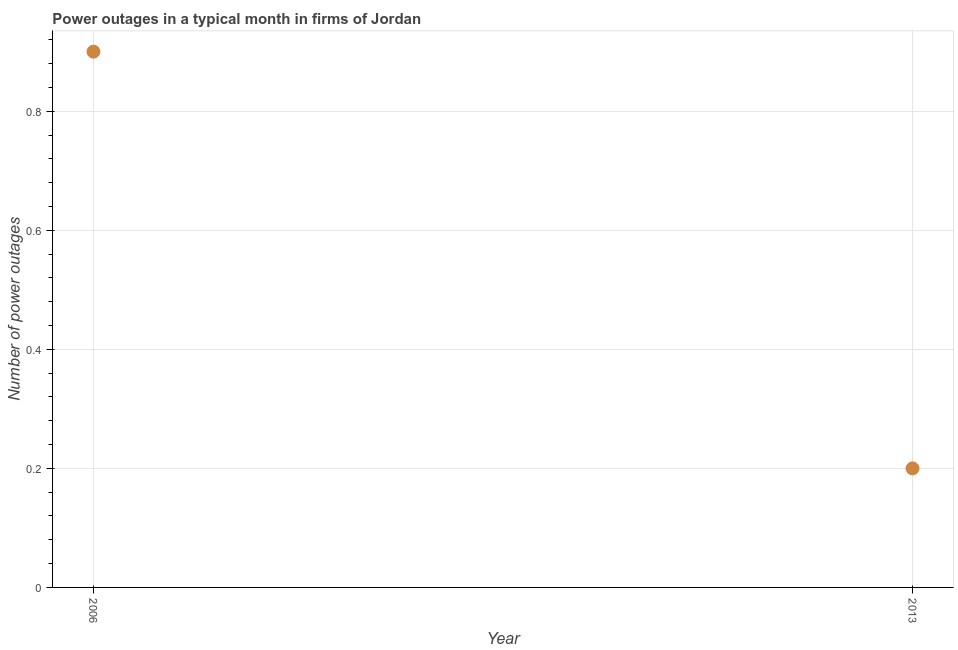Across all years, what is the maximum number of power outages?
Keep it short and to the point. 0.9. Across all years, what is the minimum number of power outages?
Provide a short and direct response. 0.2. In which year was the number of power outages minimum?
Offer a very short reply. 2013. What is the difference between the number of power outages in 2006 and 2013?
Make the answer very short. 0.7. What is the average number of power outages per year?
Your answer should be compact. 0.55. What is the median number of power outages?
Keep it short and to the point. 0.55. In how many years, is the number of power outages greater than 0.36 ?
Your response must be concise. 1. Do a majority of the years between 2006 and 2013 (inclusive) have number of power outages greater than 0.4 ?
Give a very brief answer. No. In how many years, is the number of power outages greater than the average number of power outages taken over all years?
Your answer should be very brief. 1. How many years are there in the graph?
Provide a succinct answer. 2. What is the difference between two consecutive major ticks on the Y-axis?
Provide a succinct answer. 0.2. What is the title of the graph?
Keep it short and to the point. Power outages in a typical month in firms of Jordan. What is the label or title of the Y-axis?
Your answer should be compact. Number of power outages. What is the Number of power outages in 2006?
Provide a succinct answer. 0.9. What is the difference between the Number of power outages in 2006 and 2013?
Offer a terse response. 0.7. What is the ratio of the Number of power outages in 2006 to that in 2013?
Your answer should be compact. 4.5. 